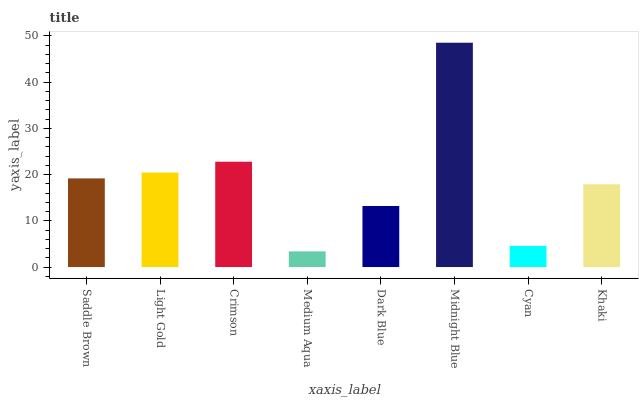Is Medium Aqua the minimum?
Answer yes or no. Yes. Is Midnight Blue the maximum?
Answer yes or no. Yes. Is Light Gold the minimum?
Answer yes or no. No. Is Light Gold the maximum?
Answer yes or no. No. Is Light Gold greater than Saddle Brown?
Answer yes or no. Yes. Is Saddle Brown less than Light Gold?
Answer yes or no. Yes. Is Saddle Brown greater than Light Gold?
Answer yes or no. No. Is Light Gold less than Saddle Brown?
Answer yes or no. No. Is Saddle Brown the high median?
Answer yes or no. Yes. Is Khaki the low median?
Answer yes or no. Yes. Is Light Gold the high median?
Answer yes or no. No. Is Light Gold the low median?
Answer yes or no. No. 